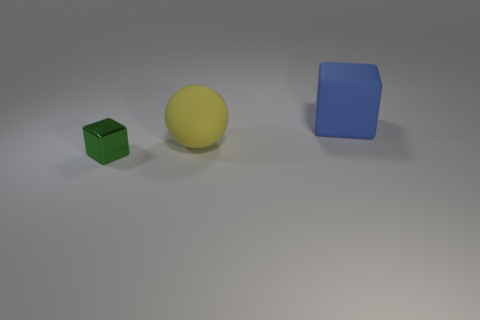Add 1 tiny green shiny things. How many objects exist? 4 Subtract all spheres. How many objects are left? 2 Add 1 purple rubber spheres. How many purple rubber spheres exist? 1 Subtract 0 yellow blocks. How many objects are left? 3 Subtract all large yellow spheres. Subtract all yellow balls. How many objects are left? 1 Add 3 blue cubes. How many blue cubes are left? 4 